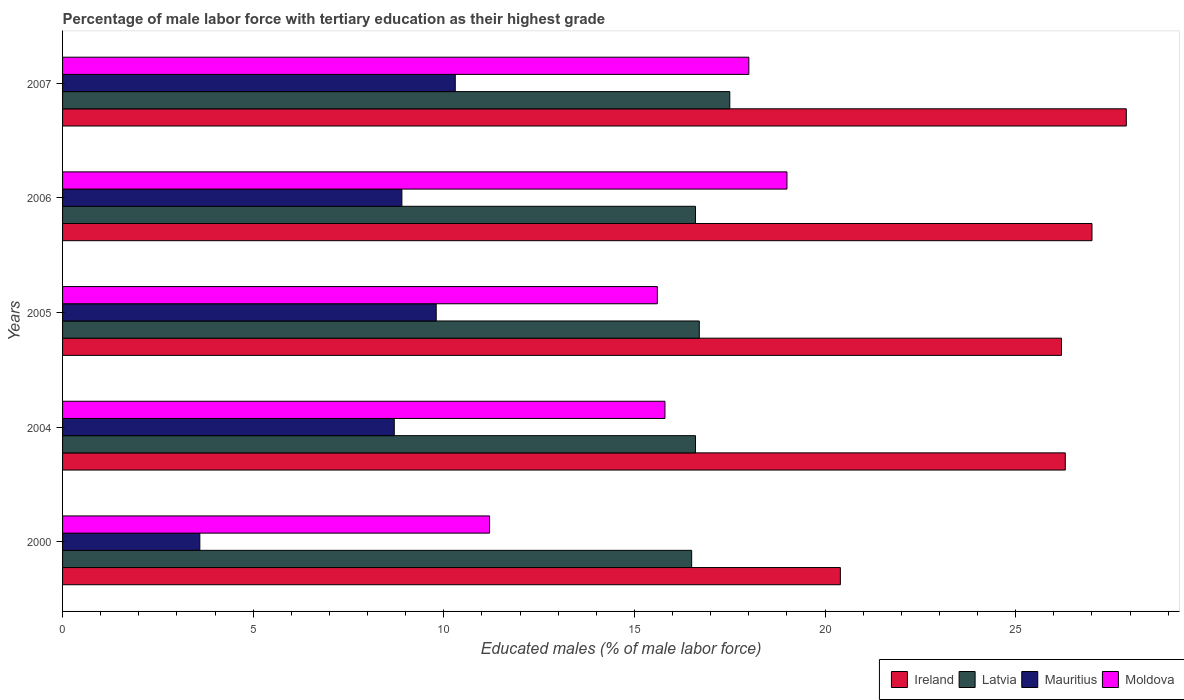Are the number of bars on each tick of the Y-axis equal?
Provide a short and direct response. Yes. What is the percentage of male labor force with tertiary education in Latvia in 2004?
Your answer should be very brief. 16.6. Across all years, what is the maximum percentage of male labor force with tertiary education in Mauritius?
Give a very brief answer. 10.3. In which year was the percentage of male labor force with tertiary education in Mauritius maximum?
Make the answer very short. 2007. In which year was the percentage of male labor force with tertiary education in Ireland minimum?
Ensure brevity in your answer.  2000. What is the total percentage of male labor force with tertiary education in Moldova in the graph?
Offer a very short reply. 79.6. What is the difference between the percentage of male labor force with tertiary education in Moldova in 2000 and that in 2005?
Your response must be concise. -4.4. What is the difference between the percentage of male labor force with tertiary education in Moldova in 2000 and the percentage of male labor force with tertiary education in Mauritius in 2007?
Your response must be concise. 0.9. What is the average percentage of male labor force with tertiary education in Latvia per year?
Your answer should be compact. 16.78. In the year 2005, what is the difference between the percentage of male labor force with tertiary education in Latvia and percentage of male labor force with tertiary education in Mauritius?
Provide a short and direct response. 6.9. What is the ratio of the percentage of male labor force with tertiary education in Ireland in 2000 to that in 2007?
Provide a short and direct response. 0.73. Is the percentage of male labor force with tertiary education in Mauritius in 2004 less than that in 2006?
Give a very brief answer. Yes. What is the difference between the highest and the second highest percentage of male labor force with tertiary education in Mauritius?
Your answer should be compact. 0.5. What is the difference between the highest and the lowest percentage of male labor force with tertiary education in Moldova?
Your response must be concise. 7.8. In how many years, is the percentage of male labor force with tertiary education in Mauritius greater than the average percentage of male labor force with tertiary education in Mauritius taken over all years?
Your response must be concise. 4. Is it the case that in every year, the sum of the percentage of male labor force with tertiary education in Moldova and percentage of male labor force with tertiary education in Mauritius is greater than the sum of percentage of male labor force with tertiary education in Ireland and percentage of male labor force with tertiary education in Latvia?
Your answer should be compact. No. What does the 2nd bar from the top in 2006 represents?
Offer a terse response. Mauritius. What does the 3rd bar from the bottom in 2005 represents?
Provide a short and direct response. Mauritius. Are all the bars in the graph horizontal?
Offer a very short reply. Yes. How many years are there in the graph?
Ensure brevity in your answer.  5. What is the difference between two consecutive major ticks on the X-axis?
Make the answer very short. 5. Are the values on the major ticks of X-axis written in scientific E-notation?
Your answer should be very brief. No. Does the graph contain any zero values?
Provide a succinct answer. No. How many legend labels are there?
Give a very brief answer. 4. What is the title of the graph?
Make the answer very short. Percentage of male labor force with tertiary education as their highest grade. Does "China" appear as one of the legend labels in the graph?
Keep it short and to the point. No. What is the label or title of the X-axis?
Provide a succinct answer. Educated males (% of male labor force). What is the Educated males (% of male labor force) in Ireland in 2000?
Ensure brevity in your answer.  20.4. What is the Educated males (% of male labor force) in Mauritius in 2000?
Offer a terse response. 3.6. What is the Educated males (% of male labor force) in Moldova in 2000?
Your response must be concise. 11.2. What is the Educated males (% of male labor force) of Ireland in 2004?
Give a very brief answer. 26.3. What is the Educated males (% of male labor force) of Latvia in 2004?
Offer a very short reply. 16.6. What is the Educated males (% of male labor force) of Mauritius in 2004?
Your response must be concise. 8.7. What is the Educated males (% of male labor force) of Moldova in 2004?
Your answer should be very brief. 15.8. What is the Educated males (% of male labor force) in Ireland in 2005?
Your response must be concise. 26.2. What is the Educated males (% of male labor force) of Latvia in 2005?
Make the answer very short. 16.7. What is the Educated males (% of male labor force) in Mauritius in 2005?
Offer a terse response. 9.8. What is the Educated males (% of male labor force) of Moldova in 2005?
Give a very brief answer. 15.6. What is the Educated males (% of male labor force) in Latvia in 2006?
Keep it short and to the point. 16.6. What is the Educated males (% of male labor force) in Mauritius in 2006?
Your answer should be very brief. 8.9. What is the Educated males (% of male labor force) in Moldova in 2006?
Give a very brief answer. 19. What is the Educated males (% of male labor force) in Ireland in 2007?
Keep it short and to the point. 27.9. What is the Educated males (% of male labor force) in Mauritius in 2007?
Offer a terse response. 10.3. What is the Educated males (% of male labor force) in Moldova in 2007?
Keep it short and to the point. 18. Across all years, what is the maximum Educated males (% of male labor force) in Ireland?
Your answer should be compact. 27.9. Across all years, what is the maximum Educated males (% of male labor force) of Latvia?
Ensure brevity in your answer.  17.5. Across all years, what is the maximum Educated males (% of male labor force) in Mauritius?
Keep it short and to the point. 10.3. Across all years, what is the maximum Educated males (% of male labor force) in Moldova?
Your response must be concise. 19. Across all years, what is the minimum Educated males (% of male labor force) in Ireland?
Give a very brief answer. 20.4. Across all years, what is the minimum Educated males (% of male labor force) of Mauritius?
Provide a succinct answer. 3.6. Across all years, what is the minimum Educated males (% of male labor force) in Moldova?
Make the answer very short. 11.2. What is the total Educated males (% of male labor force) in Ireland in the graph?
Your answer should be compact. 127.8. What is the total Educated males (% of male labor force) of Latvia in the graph?
Provide a short and direct response. 83.9. What is the total Educated males (% of male labor force) of Mauritius in the graph?
Offer a very short reply. 41.3. What is the total Educated males (% of male labor force) of Moldova in the graph?
Provide a succinct answer. 79.6. What is the difference between the Educated males (% of male labor force) of Ireland in 2000 and that in 2004?
Your response must be concise. -5.9. What is the difference between the Educated males (% of male labor force) of Moldova in 2000 and that in 2004?
Provide a short and direct response. -4.6. What is the difference between the Educated males (% of male labor force) in Ireland in 2000 and that in 2005?
Provide a succinct answer. -5.8. What is the difference between the Educated males (% of male labor force) of Latvia in 2000 and that in 2005?
Keep it short and to the point. -0.2. What is the difference between the Educated males (% of male labor force) in Moldova in 2000 and that in 2005?
Offer a very short reply. -4.4. What is the difference between the Educated males (% of male labor force) of Ireland in 2000 and that in 2006?
Make the answer very short. -6.6. What is the difference between the Educated males (% of male labor force) of Mauritius in 2000 and that in 2006?
Give a very brief answer. -5.3. What is the difference between the Educated males (% of male labor force) in Ireland in 2000 and that in 2007?
Make the answer very short. -7.5. What is the difference between the Educated males (% of male labor force) in Latvia in 2000 and that in 2007?
Your response must be concise. -1. What is the difference between the Educated males (% of male labor force) in Latvia in 2004 and that in 2005?
Offer a very short reply. -0.1. What is the difference between the Educated males (% of male labor force) of Moldova in 2004 and that in 2005?
Your answer should be compact. 0.2. What is the difference between the Educated males (% of male labor force) of Ireland in 2004 and that in 2006?
Provide a succinct answer. -0.7. What is the difference between the Educated males (% of male labor force) in Moldova in 2004 and that in 2006?
Provide a short and direct response. -3.2. What is the difference between the Educated males (% of male labor force) in Ireland in 2004 and that in 2007?
Your response must be concise. -1.6. What is the difference between the Educated males (% of male labor force) of Latvia in 2004 and that in 2007?
Your answer should be compact. -0.9. What is the difference between the Educated males (% of male labor force) of Mauritius in 2004 and that in 2007?
Provide a short and direct response. -1.6. What is the difference between the Educated males (% of male labor force) in Moldova in 2004 and that in 2007?
Your answer should be very brief. -2.2. What is the difference between the Educated males (% of male labor force) in Latvia in 2005 and that in 2006?
Offer a very short reply. 0.1. What is the difference between the Educated males (% of male labor force) in Latvia in 2005 and that in 2007?
Your response must be concise. -0.8. What is the difference between the Educated males (% of male labor force) in Moldova in 2005 and that in 2007?
Keep it short and to the point. -2.4. What is the difference between the Educated males (% of male labor force) in Mauritius in 2006 and that in 2007?
Ensure brevity in your answer.  -1.4. What is the difference between the Educated males (% of male labor force) in Moldova in 2006 and that in 2007?
Keep it short and to the point. 1. What is the difference between the Educated males (% of male labor force) in Ireland in 2000 and the Educated males (% of male labor force) in Mauritius in 2004?
Your response must be concise. 11.7. What is the difference between the Educated males (% of male labor force) of Ireland in 2000 and the Educated males (% of male labor force) of Moldova in 2004?
Your answer should be very brief. 4.6. What is the difference between the Educated males (% of male labor force) in Latvia in 2000 and the Educated males (% of male labor force) in Mauritius in 2004?
Provide a short and direct response. 7.8. What is the difference between the Educated males (% of male labor force) in Mauritius in 2000 and the Educated males (% of male labor force) in Moldova in 2004?
Give a very brief answer. -12.2. What is the difference between the Educated males (% of male labor force) in Ireland in 2000 and the Educated males (% of male labor force) in Latvia in 2005?
Offer a very short reply. 3.7. What is the difference between the Educated males (% of male labor force) of Mauritius in 2000 and the Educated males (% of male labor force) of Moldova in 2006?
Provide a succinct answer. -15.4. What is the difference between the Educated males (% of male labor force) in Ireland in 2000 and the Educated males (% of male labor force) in Mauritius in 2007?
Your response must be concise. 10.1. What is the difference between the Educated males (% of male labor force) of Mauritius in 2000 and the Educated males (% of male labor force) of Moldova in 2007?
Your answer should be compact. -14.4. What is the difference between the Educated males (% of male labor force) in Latvia in 2004 and the Educated males (% of male labor force) in Mauritius in 2005?
Ensure brevity in your answer.  6.8. What is the difference between the Educated males (% of male labor force) of Ireland in 2004 and the Educated males (% of male labor force) of Latvia in 2006?
Provide a short and direct response. 9.7. What is the difference between the Educated males (% of male labor force) in Ireland in 2004 and the Educated males (% of male labor force) in Mauritius in 2006?
Your answer should be very brief. 17.4. What is the difference between the Educated males (% of male labor force) of Ireland in 2004 and the Educated males (% of male labor force) of Mauritius in 2007?
Ensure brevity in your answer.  16. What is the difference between the Educated males (% of male labor force) of Latvia in 2004 and the Educated males (% of male labor force) of Mauritius in 2007?
Offer a terse response. 6.3. What is the difference between the Educated males (% of male labor force) in Mauritius in 2004 and the Educated males (% of male labor force) in Moldova in 2007?
Provide a short and direct response. -9.3. What is the difference between the Educated males (% of male labor force) of Ireland in 2005 and the Educated males (% of male labor force) of Mauritius in 2006?
Make the answer very short. 17.3. What is the difference between the Educated males (% of male labor force) of Latvia in 2005 and the Educated males (% of male labor force) of Mauritius in 2006?
Your answer should be compact. 7.8. What is the difference between the Educated males (% of male labor force) of Mauritius in 2005 and the Educated males (% of male labor force) of Moldova in 2006?
Offer a very short reply. -9.2. What is the difference between the Educated males (% of male labor force) in Ireland in 2005 and the Educated males (% of male labor force) in Moldova in 2007?
Provide a short and direct response. 8.2. What is the difference between the Educated males (% of male labor force) in Latvia in 2005 and the Educated males (% of male labor force) in Moldova in 2007?
Offer a very short reply. -1.3. What is the difference between the Educated males (% of male labor force) of Ireland in 2006 and the Educated males (% of male labor force) of Latvia in 2007?
Make the answer very short. 9.5. What is the difference between the Educated males (% of male labor force) of Ireland in 2006 and the Educated males (% of male labor force) of Moldova in 2007?
Your answer should be compact. 9. What is the difference between the Educated males (% of male labor force) of Latvia in 2006 and the Educated males (% of male labor force) of Mauritius in 2007?
Your answer should be very brief. 6.3. What is the difference between the Educated males (% of male labor force) in Latvia in 2006 and the Educated males (% of male labor force) in Moldova in 2007?
Your response must be concise. -1.4. What is the difference between the Educated males (% of male labor force) in Mauritius in 2006 and the Educated males (% of male labor force) in Moldova in 2007?
Provide a succinct answer. -9.1. What is the average Educated males (% of male labor force) in Ireland per year?
Provide a succinct answer. 25.56. What is the average Educated males (% of male labor force) of Latvia per year?
Ensure brevity in your answer.  16.78. What is the average Educated males (% of male labor force) of Mauritius per year?
Offer a terse response. 8.26. What is the average Educated males (% of male labor force) in Moldova per year?
Offer a terse response. 15.92. In the year 2000, what is the difference between the Educated males (% of male labor force) in Ireland and Educated males (% of male labor force) in Mauritius?
Your response must be concise. 16.8. In the year 2000, what is the difference between the Educated males (% of male labor force) in Ireland and Educated males (% of male labor force) in Moldova?
Ensure brevity in your answer.  9.2. In the year 2004, what is the difference between the Educated males (% of male labor force) in Ireland and Educated males (% of male labor force) in Mauritius?
Your answer should be compact. 17.6. In the year 2005, what is the difference between the Educated males (% of male labor force) of Ireland and Educated males (% of male labor force) of Mauritius?
Make the answer very short. 16.4. In the year 2005, what is the difference between the Educated males (% of male labor force) in Ireland and Educated males (% of male labor force) in Moldova?
Ensure brevity in your answer.  10.6. In the year 2005, what is the difference between the Educated males (% of male labor force) of Latvia and Educated males (% of male labor force) of Mauritius?
Your answer should be very brief. 6.9. In the year 2005, what is the difference between the Educated males (% of male labor force) of Latvia and Educated males (% of male labor force) of Moldova?
Your answer should be compact. 1.1. In the year 2006, what is the difference between the Educated males (% of male labor force) in Ireland and Educated males (% of male labor force) in Latvia?
Offer a very short reply. 10.4. In the year 2006, what is the difference between the Educated males (% of male labor force) of Ireland and Educated males (% of male labor force) of Mauritius?
Your response must be concise. 18.1. In the year 2006, what is the difference between the Educated males (% of male labor force) in Mauritius and Educated males (% of male labor force) in Moldova?
Make the answer very short. -10.1. In the year 2007, what is the difference between the Educated males (% of male labor force) of Ireland and Educated males (% of male labor force) of Latvia?
Keep it short and to the point. 10.4. In the year 2007, what is the difference between the Educated males (% of male labor force) of Ireland and Educated males (% of male labor force) of Mauritius?
Ensure brevity in your answer.  17.6. In the year 2007, what is the difference between the Educated males (% of male labor force) of Ireland and Educated males (% of male labor force) of Moldova?
Your response must be concise. 9.9. In the year 2007, what is the difference between the Educated males (% of male labor force) of Latvia and Educated males (% of male labor force) of Moldova?
Give a very brief answer. -0.5. What is the ratio of the Educated males (% of male labor force) in Ireland in 2000 to that in 2004?
Your response must be concise. 0.78. What is the ratio of the Educated males (% of male labor force) in Latvia in 2000 to that in 2004?
Give a very brief answer. 0.99. What is the ratio of the Educated males (% of male labor force) in Mauritius in 2000 to that in 2004?
Your answer should be compact. 0.41. What is the ratio of the Educated males (% of male labor force) in Moldova in 2000 to that in 2004?
Give a very brief answer. 0.71. What is the ratio of the Educated males (% of male labor force) in Ireland in 2000 to that in 2005?
Make the answer very short. 0.78. What is the ratio of the Educated males (% of male labor force) of Latvia in 2000 to that in 2005?
Ensure brevity in your answer.  0.99. What is the ratio of the Educated males (% of male labor force) of Mauritius in 2000 to that in 2005?
Offer a very short reply. 0.37. What is the ratio of the Educated males (% of male labor force) of Moldova in 2000 to that in 2005?
Provide a succinct answer. 0.72. What is the ratio of the Educated males (% of male labor force) of Ireland in 2000 to that in 2006?
Keep it short and to the point. 0.76. What is the ratio of the Educated males (% of male labor force) of Mauritius in 2000 to that in 2006?
Provide a succinct answer. 0.4. What is the ratio of the Educated males (% of male labor force) in Moldova in 2000 to that in 2006?
Your answer should be very brief. 0.59. What is the ratio of the Educated males (% of male labor force) of Ireland in 2000 to that in 2007?
Your answer should be very brief. 0.73. What is the ratio of the Educated males (% of male labor force) of Latvia in 2000 to that in 2007?
Keep it short and to the point. 0.94. What is the ratio of the Educated males (% of male labor force) of Mauritius in 2000 to that in 2007?
Make the answer very short. 0.35. What is the ratio of the Educated males (% of male labor force) of Moldova in 2000 to that in 2007?
Your answer should be compact. 0.62. What is the ratio of the Educated males (% of male labor force) in Ireland in 2004 to that in 2005?
Provide a short and direct response. 1. What is the ratio of the Educated males (% of male labor force) in Latvia in 2004 to that in 2005?
Provide a short and direct response. 0.99. What is the ratio of the Educated males (% of male labor force) of Mauritius in 2004 to that in 2005?
Give a very brief answer. 0.89. What is the ratio of the Educated males (% of male labor force) of Moldova in 2004 to that in 2005?
Offer a terse response. 1.01. What is the ratio of the Educated males (% of male labor force) in Ireland in 2004 to that in 2006?
Ensure brevity in your answer.  0.97. What is the ratio of the Educated males (% of male labor force) in Latvia in 2004 to that in 2006?
Your response must be concise. 1. What is the ratio of the Educated males (% of male labor force) in Mauritius in 2004 to that in 2006?
Your answer should be very brief. 0.98. What is the ratio of the Educated males (% of male labor force) in Moldova in 2004 to that in 2006?
Keep it short and to the point. 0.83. What is the ratio of the Educated males (% of male labor force) of Ireland in 2004 to that in 2007?
Your response must be concise. 0.94. What is the ratio of the Educated males (% of male labor force) in Latvia in 2004 to that in 2007?
Provide a short and direct response. 0.95. What is the ratio of the Educated males (% of male labor force) in Mauritius in 2004 to that in 2007?
Your response must be concise. 0.84. What is the ratio of the Educated males (% of male labor force) of Moldova in 2004 to that in 2007?
Your response must be concise. 0.88. What is the ratio of the Educated males (% of male labor force) in Ireland in 2005 to that in 2006?
Make the answer very short. 0.97. What is the ratio of the Educated males (% of male labor force) in Latvia in 2005 to that in 2006?
Provide a succinct answer. 1.01. What is the ratio of the Educated males (% of male labor force) of Mauritius in 2005 to that in 2006?
Your response must be concise. 1.1. What is the ratio of the Educated males (% of male labor force) of Moldova in 2005 to that in 2006?
Keep it short and to the point. 0.82. What is the ratio of the Educated males (% of male labor force) of Ireland in 2005 to that in 2007?
Give a very brief answer. 0.94. What is the ratio of the Educated males (% of male labor force) in Latvia in 2005 to that in 2007?
Your answer should be compact. 0.95. What is the ratio of the Educated males (% of male labor force) in Mauritius in 2005 to that in 2007?
Make the answer very short. 0.95. What is the ratio of the Educated males (% of male labor force) of Moldova in 2005 to that in 2007?
Your response must be concise. 0.87. What is the ratio of the Educated males (% of male labor force) of Latvia in 2006 to that in 2007?
Ensure brevity in your answer.  0.95. What is the ratio of the Educated males (% of male labor force) in Mauritius in 2006 to that in 2007?
Ensure brevity in your answer.  0.86. What is the ratio of the Educated males (% of male labor force) in Moldova in 2006 to that in 2007?
Make the answer very short. 1.06. What is the difference between the highest and the second highest Educated males (% of male labor force) of Ireland?
Give a very brief answer. 0.9. What is the difference between the highest and the second highest Educated males (% of male labor force) in Mauritius?
Your response must be concise. 0.5. What is the difference between the highest and the lowest Educated males (% of male labor force) in Mauritius?
Your answer should be compact. 6.7. What is the difference between the highest and the lowest Educated males (% of male labor force) of Moldova?
Provide a short and direct response. 7.8. 